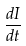Convert formula to latex. <formula><loc_0><loc_0><loc_500><loc_500>\frac { d I } { d t }</formula> 